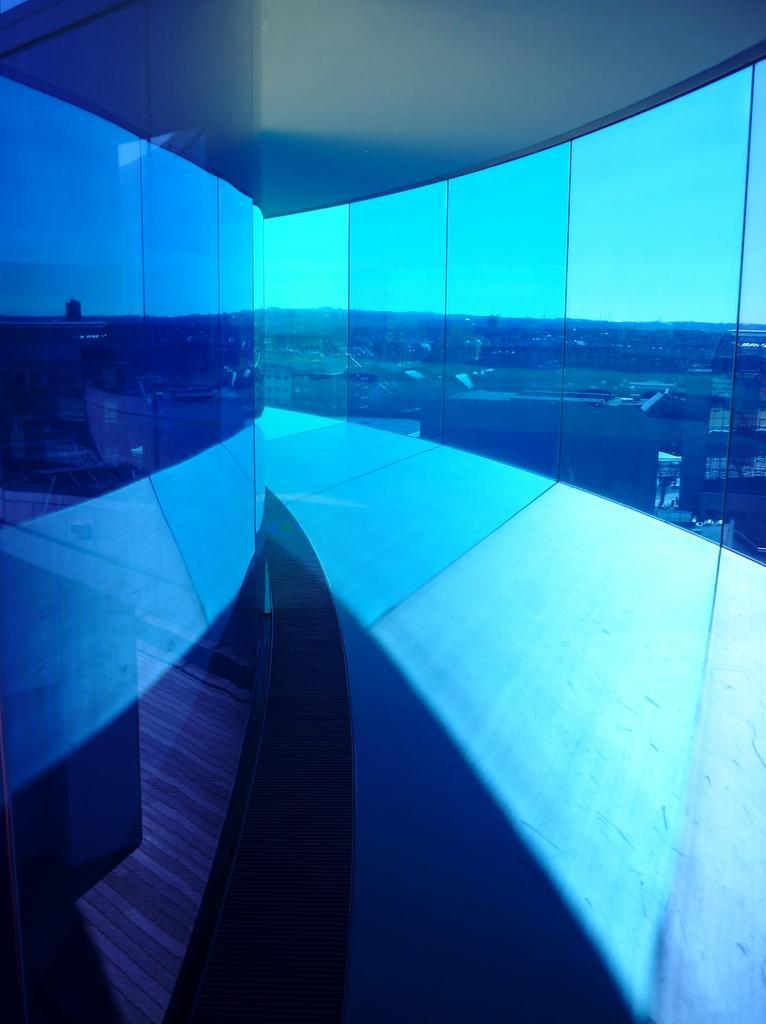In one or two sentences, can you explain what this image depicts? In this picture I can see the glass wall. 